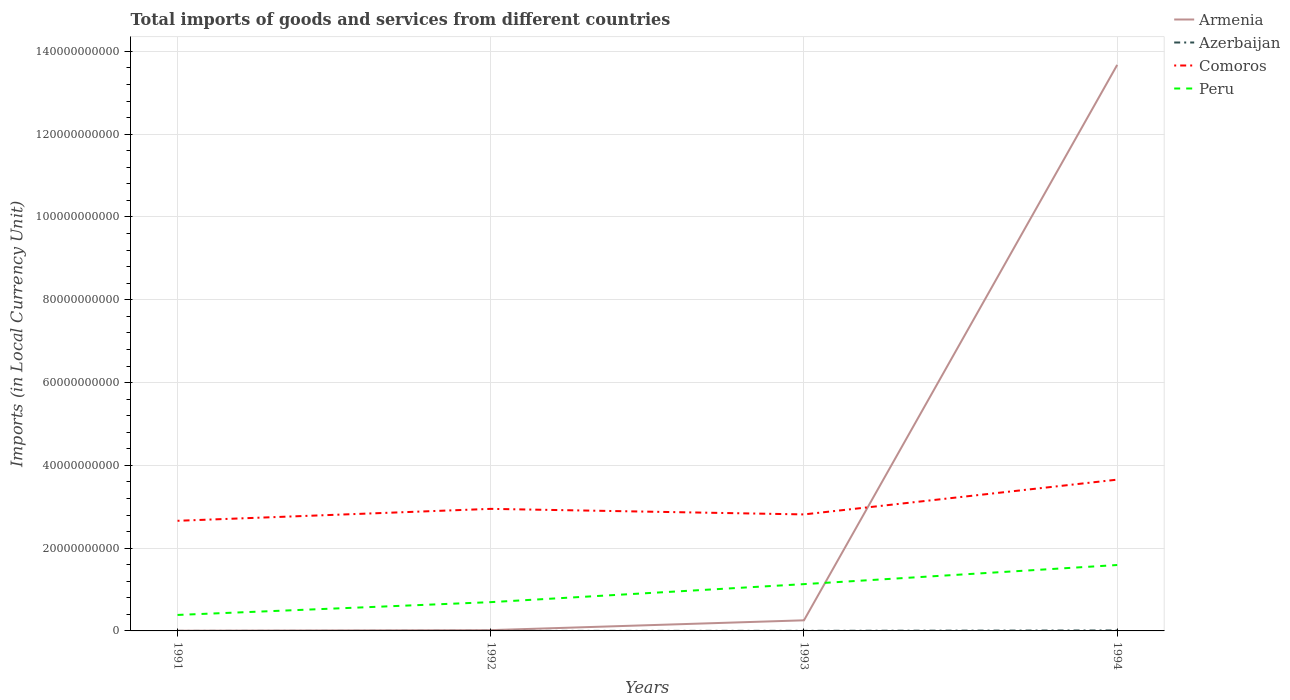How many different coloured lines are there?
Offer a very short reply. 4. Is the number of lines equal to the number of legend labels?
Give a very brief answer. Yes. Across all years, what is the maximum Amount of goods and services imports in Comoros?
Offer a terse response. 2.66e+1. In which year was the Amount of goods and services imports in Armenia maximum?
Offer a terse response. 1991. What is the total Amount of goods and services imports in Azerbaijan in the graph?
Offer a very short reply. -2.41e+06. What is the difference between the highest and the second highest Amount of goods and services imports in Armenia?
Give a very brief answer. 1.37e+11. What is the difference between the highest and the lowest Amount of goods and services imports in Peru?
Your answer should be compact. 2. Is the Amount of goods and services imports in Comoros strictly greater than the Amount of goods and services imports in Peru over the years?
Provide a succinct answer. No. How many lines are there?
Offer a terse response. 4. Are the values on the major ticks of Y-axis written in scientific E-notation?
Give a very brief answer. No. Does the graph contain grids?
Make the answer very short. Yes. Where does the legend appear in the graph?
Your answer should be compact. Top right. How are the legend labels stacked?
Keep it short and to the point. Vertical. What is the title of the graph?
Your response must be concise. Total imports of goods and services from different countries. Does "France" appear as one of the legend labels in the graph?
Keep it short and to the point. No. What is the label or title of the X-axis?
Offer a terse response. Years. What is the label or title of the Y-axis?
Ensure brevity in your answer.  Imports (in Local Currency Unit). What is the Imports (in Local Currency Unit) of Armenia in 1991?
Offer a very short reply. 4.79e+07. What is the Imports (in Local Currency Unit) in Azerbaijan in 1991?
Provide a succinct answer. 2.20e+05. What is the Imports (in Local Currency Unit) of Comoros in 1991?
Give a very brief answer. 2.66e+1. What is the Imports (in Local Currency Unit) in Peru in 1991?
Offer a terse response. 3.86e+09. What is the Imports (in Local Currency Unit) in Armenia in 1992?
Your response must be concise. 1.90e+08. What is the Imports (in Local Currency Unit) of Azerbaijan in 1992?
Offer a very short reply. 2.63e+06. What is the Imports (in Local Currency Unit) of Comoros in 1992?
Your response must be concise. 2.95e+1. What is the Imports (in Local Currency Unit) of Peru in 1992?
Keep it short and to the point. 6.95e+09. What is the Imports (in Local Currency Unit) in Armenia in 1993?
Provide a succinct answer. 2.56e+09. What is the Imports (in Local Currency Unit) in Azerbaijan in 1993?
Offer a very short reply. 2.39e+07. What is the Imports (in Local Currency Unit) of Comoros in 1993?
Your answer should be very brief. 2.81e+1. What is the Imports (in Local Currency Unit) of Peru in 1993?
Provide a succinct answer. 1.13e+1. What is the Imports (in Local Currency Unit) of Armenia in 1994?
Give a very brief answer. 1.37e+11. What is the Imports (in Local Currency Unit) of Azerbaijan in 1994?
Provide a succinct answer. 1.15e+08. What is the Imports (in Local Currency Unit) of Comoros in 1994?
Your response must be concise. 3.65e+1. What is the Imports (in Local Currency Unit) in Peru in 1994?
Your answer should be very brief. 1.59e+1. Across all years, what is the maximum Imports (in Local Currency Unit) in Armenia?
Make the answer very short. 1.37e+11. Across all years, what is the maximum Imports (in Local Currency Unit) of Azerbaijan?
Ensure brevity in your answer.  1.15e+08. Across all years, what is the maximum Imports (in Local Currency Unit) of Comoros?
Give a very brief answer. 3.65e+1. Across all years, what is the maximum Imports (in Local Currency Unit) in Peru?
Your response must be concise. 1.59e+1. Across all years, what is the minimum Imports (in Local Currency Unit) of Armenia?
Ensure brevity in your answer.  4.79e+07. Across all years, what is the minimum Imports (in Local Currency Unit) of Azerbaijan?
Provide a succinct answer. 2.20e+05. Across all years, what is the minimum Imports (in Local Currency Unit) of Comoros?
Give a very brief answer. 2.66e+1. Across all years, what is the minimum Imports (in Local Currency Unit) of Peru?
Offer a very short reply. 3.86e+09. What is the total Imports (in Local Currency Unit) of Armenia in the graph?
Your answer should be compact. 1.40e+11. What is the total Imports (in Local Currency Unit) in Azerbaijan in the graph?
Give a very brief answer. 1.41e+08. What is the total Imports (in Local Currency Unit) in Comoros in the graph?
Provide a succinct answer. 1.21e+11. What is the total Imports (in Local Currency Unit) in Peru in the graph?
Provide a succinct answer. 3.80e+1. What is the difference between the Imports (in Local Currency Unit) in Armenia in 1991 and that in 1992?
Make the answer very short. -1.42e+08. What is the difference between the Imports (in Local Currency Unit) of Azerbaijan in 1991 and that in 1992?
Your answer should be very brief. -2.41e+06. What is the difference between the Imports (in Local Currency Unit) of Comoros in 1991 and that in 1992?
Ensure brevity in your answer.  -2.88e+09. What is the difference between the Imports (in Local Currency Unit) of Peru in 1991 and that in 1992?
Make the answer very short. -3.09e+09. What is the difference between the Imports (in Local Currency Unit) in Armenia in 1991 and that in 1993?
Give a very brief answer. -2.51e+09. What is the difference between the Imports (in Local Currency Unit) in Azerbaijan in 1991 and that in 1993?
Provide a succinct answer. -2.37e+07. What is the difference between the Imports (in Local Currency Unit) of Comoros in 1991 and that in 1993?
Your answer should be compact. -1.54e+09. What is the difference between the Imports (in Local Currency Unit) of Peru in 1991 and that in 1993?
Give a very brief answer. -7.44e+09. What is the difference between the Imports (in Local Currency Unit) of Armenia in 1991 and that in 1994?
Provide a succinct answer. -1.37e+11. What is the difference between the Imports (in Local Currency Unit) of Azerbaijan in 1991 and that in 1994?
Offer a terse response. -1.15e+08. What is the difference between the Imports (in Local Currency Unit) in Comoros in 1991 and that in 1994?
Offer a very short reply. -9.94e+09. What is the difference between the Imports (in Local Currency Unit) of Peru in 1991 and that in 1994?
Your response must be concise. -1.21e+1. What is the difference between the Imports (in Local Currency Unit) of Armenia in 1992 and that in 1993?
Your response must be concise. -2.37e+09. What is the difference between the Imports (in Local Currency Unit) in Azerbaijan in 1992 and that in 1993?
Your answer should be compact. -2.12e+07. What is the difference between the Imports (in Local Currency Unit) in Comoros in 1992 and that in 1993?
Make the answer very short. 1.34e+09. What is the difference between the Imports (in Local Currency Unit) in Peru in 1992 and that in 1993?
Your answer should be very brief. -4.35e+09. What is the difference between the Imports (in Local Currency Unit) of Armenia in 1992 and that in 1994?
Give a very brief answer. -1.37e+11. What is the difference between the Imports (in Local Currency Unit) of Azerbaijan in 1992 and that in 1994?
Give a very brief answer. -1.12e+08. What is the difference between the Imports (in Local Currency Unit) in Comoros in 1992 and that in 1994?
Keep it short and to the point. -7.06e+09. What is the difference between the Imports (in Local Currency Unit) in Peru in 1992 and that in 1994?
Keep it short and to the point. -8.97e+09. What is the difference between the Imports (in Local Currency Unit) in Armenia in 1993 and that in 1994?
Make the answer very short. -1.34e+11. What is the difference between the Imports (in Local Currency Unit) of Azerbaijan in 1993 and that in 1994?
Keep it short and to the point. -9.09e+07. What is the difference between the Imports (in Local Currency Unit) of Comoros in 1993 and that in 1994?
Provide a short and direct response. -8.40e+09. What is the difference between the Imports (in Local Currency Unit) in Peru in 1993 and that in 1994?
Provide a succinct answer. -4.62e+09. What is the difference between the Imports (in Local Currency Unit) in Armenia in 1991 and the Imports (in Local Currency Unit) in Azerbaijan in 1992?
Provide a succinct answer. 4.53e+07. What is the difference between the Imports (in Local Currency Unit) of Armenia in 1991 and the Imports (in Local Currency Unit) of Comoros in 1992?
Your answer should be very brief. -2.94e+1. What is the difference between the Imports (in Local Currency Unit) in Armenia in 1991 and the Imports (in Local Currency Unit) in Peru in 1992?
Provide a short and direct response. -6.91e+09. What is the difference between the Imports (in Local Currency Unit) of Azerbaijan in 1991 and the Imports (in Local Currency Unit) of Comoros in 1992?
Ensure brevity in your answer.  -2.95e+1. What is the difference between the Imports (in Local Currency Unit) in Azerbaijan in 1991 and the Imports (in Local Currency Unit) in Peru in 1992?
Provide a succinct answer. -6.95e+09. What is the difference between the Imports (in Local Currency Unit) in Comoros in 1991 and the Imports (in Local Currency Unit) in Peru in 1992?
Offer a very short reply. 1.96e+1. What is the difference between the Imports (in Local Currency Unit) in Armenia in 1991 and the Imports (in Local Currency Unit) in Azerbaijan in 1993?
Offer a very short reply. 2.40e+07. What is the difference between the Imports (in Local Currency Unit) of Armenia in 1991 and the Imports (in Local Currency Unit) of Comoros in 1993?
Make the answer very short. -2.81e+1. What is the difference between the Imports (in Local Currency Unit) of Armenia in 1991 and the Imports (in Local Currency Unit) of Peru in 1993?
Offer a very short reply. -1.13e+1. What is the difference between the Imports (in Local Currency Unit) of Azerbaijan in 1991 and the Imports (in Local Currency Unit) of Comoros in 1993?
Your answer should be very brief. -2.81e+1. What is the difference between the Imports (in Local Currency Unit) of Azerbaijan in 1991 and the Imports (in Local Currency Unit) of Peru in 1993?
Your response must be concise. -1.13e+1. What is the difference between the Imports (in Local Currency Unit) in Comoros in 1991 and the Imports (in Local Currency Unit) in Peru in 1993?
Keep it short and to the point. 1.53e+1. What is the difference between the Imports (in Local Currency Unit) of Armenia in 1991 and the Imports (in Local Currency Unit) of Azerbaijan in 1994?
Your response must be concise. -6.69e+07. What is the difference between the Imports (in Local Currency Unit) in Armenia in 1991 and the Imports (in Local Currency Unit) in Comoros in 1994?
Keep it short and to the point. -3.65e+1. What is the difference between the Imports (in Local Currency Unit) of Armenia in 1991 and the Imports (in Local Currency Unit) of Peru in 1994?
Provide a short and direct response. -1.59e+1. What is the difference between the Imports (in Local Currency Unit) in Azerbaijan in 1991 and the Imports (in Local Currency Unit) in Comoros in 1994?
Offer a very short reply. -3.65e+1. What is the difference between the Imports (in Local Currency Unit) of Azerbaijan in 1991 and the Imports (in Local Currency Unit) of Peru in 1994?
Your answer should be compact. -1.59e+1. What is the difference between the Imports (in Local Currency Unit) in Comoros in 1991 and the Imports (in Local Currency Unit) in Peru in 1994?
Make the answer very short. 1.07e+1. What is the difference between the Imports (in Local Currency Unit) of Armenia in 1992 and the Imports (in Local Currency Unit) of Azerbaijan in 1993?
Ensure brevity in your answer.  1.66e+08. What is the difference between the Imports (in Local Currency Unit) in Armenia in 1992 and the Imports (in Local Currency Unit) in Comoros in 1993?
Ensure brevity in your answer.  -2.80e+1. What is the difference between the Imports (in Local Currency Unit) of Armenia in 1992 and the Imports (in Local Currency Unit) of Peru in 1993?
Offer a very short reply. -1.11e+1. What is the difference between the Imports (in Local Currency Unit) in Azerbaijan in 1992 and the Imports (in Local Currency Unit) in Comoros in 1993?
Your answer should be very brief. -2.81e+1. What is the difference between the Imports (in Local Currency Unit) in Azerbaijan in 1992 and the Imports (in Local Currency Unit) in Peru in 1993?
Provide a short and direct response. -1.13e+1. What is the difference between the Imports (in Local Currency Unit) in Comoros in 1992 and the Imports (in Local Currency Unit) in Peru in 1993?
Make the answer very short. 1.82e+1. What is the difference between the Imports (in Local Currency Unit) of Armenia in 1992 and the Imports (in Local Currency Unit) of Azerbaijan in 1994?
Offer a very short reply. 7.52e+07. What is the difference between the Imports (in Local Currency Unit) of Armenia in 1992 and the Imports (in Local Currency Unit) of Comoros in 1994?
Ensure brevity in your answer.  -3.64e+1. What is the difference between the Imports (in Local Currency Unit) in Armenia in 1992 and the Imports (in Local Currency Unit) in Peru in 1994?
Your answer should be compact. -1.57e+1. What is the difference between the Imports (in Local Currency Unit) of Azerbaijan in 1992 and the Imports (in Local Currency Unit) of Comoros in 1994?
Your answer should be compact. -3.65e+1. What is the difference between the Imports (in Local Currency Unit) of Azerbaijan in 1992 and the Imports (in Local Currency Unit) of Peru in 1994?
Give a very brief answer. -1.59e+1. What is the difference between the Imports (in Local Currency Unit) in Comoros in 1992 and the Imports (in Local Currency Unit) in Peru in 1994?
Offer a terse response. 1.36e+1. What is the difference between the Imports (in Local Currency Unit) in Armenia in 1993 and the Imports (in Local Currency Unit) in Azerbaijan in 1994?
Offer a terse response. 2.45e+09. What is the difference between the Imports (in Local Currency Unit) of Armenia in 1993 and the Imports (in Local Currency Unit) of Comoros in 1994?
Provide a succinct answer. -3.40e+1. What is the difference between the Imports (in Local Currency Unit) of Armenia in 1993 and the Imports (in Local Currency Unit) of Peru in 1994?
Offer a terse response. -1.34e+1. What is the difference between the Imports (in Local Currency Unit) of Azerbaijan in 1993 and the Imports (in Local Currency Unit) of Comoros in 1994?
Offer a terse response. -3.65e+1. What is the difference between the Imports (in Local Currency Unit) in Azerbaijan in 1993 and the Imports (in Local Currency Unit) in Peru in 1994?
Offer a terse response. -1.59e+1. What is the difference between the Imports (in Local Currency Unit) of Comoros in 1993 and the Imports (in Local Currency Unit) of Peru in 1994?
Your response must be concise. 1.22e+1. What is the average Imports (in Local Currency Unit) in Armenia per year?
Your response must be concise. 3.49e+1. What is the average Imports (in Local Currency Unit) in Azerbaijan per year?
Your answer should be compact. 3.54e+07. What is the average Imports (in Local Currency Unit) of Comoros per year?
Your answer should be compact. 3.02e+1. What is the average Imports (in Local Currency Unit) of Peru per year?
Give a very brief answer. 9.51e+09. In the year 1991, what is the difference between the Imports (in Local Currency Unit) of Armenia and Imports (in Local Currency Unit) of Azerbaijan?
Give a very brief answer. 4.77e+07. In the year 1991, what is the difference between the Imports (in Local Currency Unit) of Armenia and Imports (in Local Currency Unit) of Comoros?
Give a very brief answer. -2.66e+1. In the year 1991, what is the difference between the Imports (in Local Currency Unit) in Armenia and Imports (in Local Currency Unit) in Peru?
Give a very brief answer. -3.81e+09. In the year 1991, what is the difference between the Imports (in Local Currency Unit) of Azerbaijan and Imports (in Local Currency Unit) of Comoros?
Ensure brevity in your answer.  -2.66e+1. In the year 1991, what is the difference between the Imports (in Local Currency Unit) in Azerbaijan and Imports (in Local Currency Unit) in Peru?
Your answer should be compact. -3.86e+09. In the year 1991, what is the difference between the Imports (in Local Currency Unit) of Comoros and Imports (in Local Currency Unit) of Peru?
Make the answer very short. 2.27e+1. In the year 1992, what is the difference between the Imports (in Local Currency Unit) of Armenia and Imports (in Local Currency Unit) of Azerbaijan?
Provide a succinct answer. 1.87e+08. In the year 1992, what is the difference between the Imports (in Local Currency Unit) in Armenia and Imports (in Local Currency Unit) in Comoros?
Your answer should be compact. -2.93e+1. In the year 1992, what is the difference between the Imports (in Local Currency Unit) in Armenia and Imports (in Local Currency Unit) in Peru?
Provide a succinct answer. -6.76e+09. In the year 1992, what is the difference between the Imports (in Local Currency Unit) in Azerbaijan and Imports (in Local Currency Unit) in Comoros?
Keep it short and to the point. -2.95e+1. In the year 1992, what is the difference between the Imports (in Local Currency Unit) of Azerbaijan and Imports (in Local Currency Unit) of Peru?
Offer a very short reply. -6.95e+09. In the year 1992, what is the difference between the Imports (in Local Currency Unit) of Comoros and Imports (in Local Currency Unit) of Peru?
Keep it short and to the point. 2.25e+1. In the year 1993, what is the difference between the Imports (in Local Currency Unit) of Armenia and Imports (in Local Currency Unit) of Azerbaijan?
Your answer should be compact. 2.54e+09. In the year 1993, what is the difference between the Imports (in Local Currency Unit) of Armenia and Imports (in Local Currency Unit) of Comoros?
Make the answer very short. -2.56e+1. In the year 1993, what is the difference between the Imports (in Local Currency Unit) of Armenia and Imports (in Local Currency Unit) of Peru?
Ensure brevity in your answer.  -8.74e+09. In the year 1993, what is the difference between the Imports (in Local Currency Unit) in Azerbaijan and Imports (in Local Currency Unit) in Comoros?
Offer a terse response. -2.81e+1. In the year 1993, what is the difference between the Imports (in Local Currency Unit) in Azerbaijan and Imports (in Local Currency Unit) in Peru?
Offer a terse response. -1.13e+1. In the year 1993, what is the difference between the Imports (in Local Currency Unit) in Comoros and Imports (in Local Currency Unit) in Peru?
Your answer should be very brief. 1.68e+1. In the year 1994, what is the difference between the Imports (in Local Currency Unit) in Armenia and Imports (in Local Currency Unit) in Azerbaijan?
Offer a terse response. 1.37e+11. In the year 1994, what is the difference between the Imports (in Local Currency Unit) in Armenia and Imports (in Local Currency Unit) in Comoros?
Provide a succinct answer. 1.00e+11. In the year 1994, what is the difference between the Imports (in Local Currency Unit) in Armenia and Imports (in Local Currency Unit) in Peru?
Keep it short and to the point. 1.21e+11. In the year 1994, what is the difference between the Imports (in Local Currency Unit) in Azerbaijan and Imports (in Local Currency Unit) in Comoros?
Your answer should be very brief. -3.64e+1. In the year 1994, what is the difference between the Imports (in Local Currency Unit) of Azerbaijan and Imports (in Local Currency Unit) of Peru?
Your answer should be compact. -1.58e+1. In the year 1994, what is the difference between the Imports (in Local Currency Unit) in Comoros and Imports (in Local Currency Unit) in Peru?
Your answer should be compact. 2.06e+1. What is the ratio of the Imports (in Local Currency Unit) of Armenia in 1991 to that in 1992?
Offer a terse response. 0.25. What is the ratio of the Imports (in Local Currency Unit) of Azerbaijan in 1991 to that in 1992?
Your answer should be compact. 0.08. What is the ratio of the Imports (in Local Currency Unit) in Comoros in 1991 to that in 1992?
Provide a short and direct response. 0.9. What is the ratio of the Imports (in Local Currency Unit) of Peru in 1991 to that in 1992?
Provide a short and direct response. 0.56. What is the ratio of the Imports (in Local Currency Unit) in Armenia in 1991 to that in 1993?
Offer a very short reply. 0.02. What is the ratio of the Imports (in Local Currency Unit) of Azerbaijan in 1991 to that in 1993?
Provide a succinct answer. 0.01. What is the ratio of the Imports (in Local Currency Unit) in Comoros in 1991 to that in 1993?
Ensure brevity in your answer.  0.95. What is the ratio of the Imports (in Local Currency Unit) of Peru in 1991 to that in 1993?
Your answer should be very brief. 0.34. What is the ratio of the Imports (in Local Currency Unit) of Azerbaijan in 1991 to that in 1994?
Give a very brief answer. 0. What is the ratio of the Imports (in Local Currency Unit) of Comoros in 1991 to that in 1994?
Give a very brief answer. 0.73. What is the ratio of the Imports (in Local Currency Unit) in Peru in 1991 to that in 1994?
Provide a succinct answer. 0.24. What is the ratio of the Imports (in Local Currency Unit) of Armenia in 1992 to that in 1993?
Make the answer very short. 0.07. What is the ratio of the Imports (in Local Currency Unit) in Azerbaijan in 1992 to that in 1993?
Provide a short and direct response. 0.11. What is the ratio of the Imports (in Local Currency Unit) of Comoros in 1992 to that in 1993?
Give a very brief answer. 1.05. What is the ratio of the Imports (in Local Currency Unit) in Peru in 1992 to that in 1993?
Provide a succinct answer. 0.62. What is the ratio of the Imports (in Local Currency Unit) of Armenia in 1992 to that in 1994?
Offer a terse response. 0. What is the ratio of the Imports (in Local Currency Unit) of Azerbaijan in 1992 to that in 1994?
Offer a very short reply. 0.02. What is the ratio of the Imports (in Local Currency Unit) of Comoros in 1992 to that in 1994?
Keep it short and to the point. 0.81. What is the ratio of the Imports (in Local Currency Unit) of Peru in 1992 to that in 1994?
Your answer should be compact. 0.44. What is the ratio of the Imports (in Local Currency Unit) in Armenia in 1993 to that in 1994?
Make the answer very short. 0.02. What is the ratio of the Imports (in Local Currency Unit) of Azerbaijan in 1993 to that in 1994?
Keep it short and to the point. 0.21. What is the ratio of the Imports (in Local Currency Unit) in Comoros in 1993 to that in 1994?
Keep it short and to the point. 0.77. What is the ratio of the Imports (in Local Currency Unit) in Peru in 1993 to that in 1994?
Ensure brevity in your answer.  0.71. What is the difference between the highest and the second highest Imports (in Local Currency Unit) in Armenia?
Offer a very short reply. 1.34e+11. What is the difference between the highest and the second highest Imports (in Local Currency Unit) in Azerbaijan?
Offer a terse response. 9.09e+07. What is the difference between the highest and the second highest Imports (in Local Currency Unit) of Comoros?
Your answer should be very brief. 7.06e+09. What is the difference between the highest and the second highest Imports (in Local Currency Unit) of Peru?
Offer a very short reply. 4.62e+09. What is the difference between the highest and the lowest Imports (in Local Currency Unit) in Armenia?
Give a very brief answer. 1.37e+11. What is the difference between the highest and the lowest Imports (in Local Currency Unit) of Azerbaijan?
Offer a terse response. 1.15e+08. What is the difference between the highest and the lowest Imports (in Local Currency Unit) of Comoros?
Your answer should be compact. 9.94e+09. What is the difference between the highest and the lowest Imports (in Local Currency Unit) in Peru?
Your answer should be very brief. 1.21e+1. 